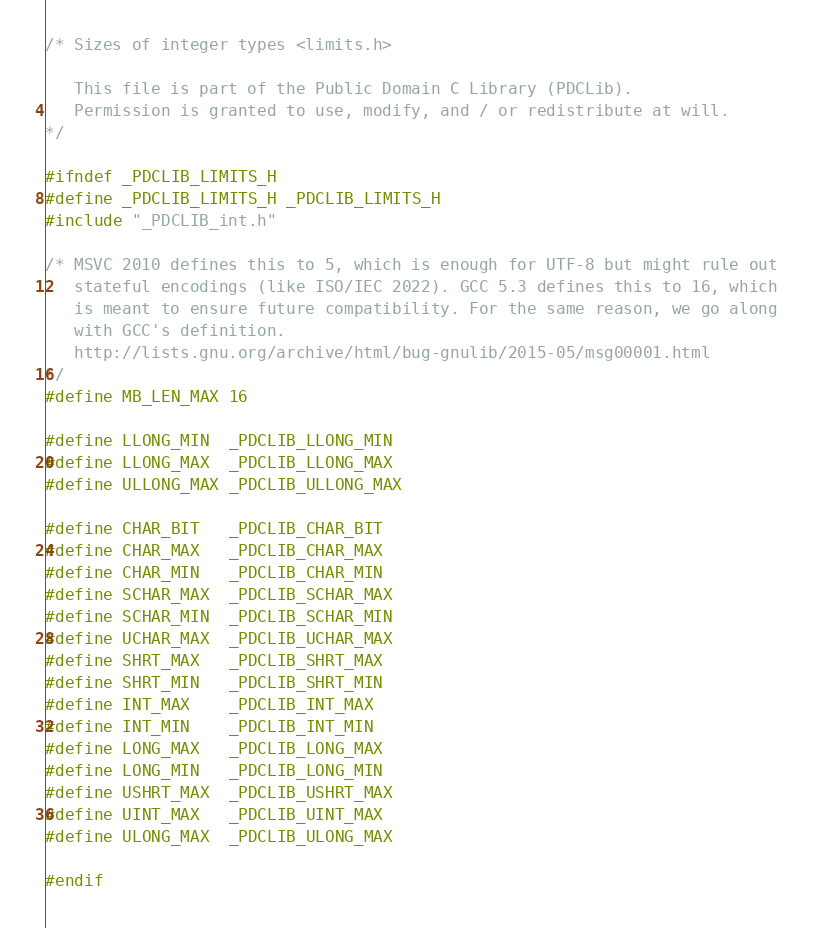Convert code to text. <code><loc_0><loc_0><loc_500><loc_500><_C_>/* Sizes of integer types <limits.h>

   This file is part of the Public Domain C Library (PDCLib).
   Permission is granted to use, modify, and / or redistribute at will.
*/

#ifndef _PDCLIB_LIMITS_H
#define _PDCLIB_LIMITS_H _PDCLIB_LIMITS_H
#include "_PDCLIB_int.h"

/* MSVC 2010 defines this to 5, which is enough for UTF-8 but might rule out
   stateful encodings (like ISO/IEC 2022). GCC 5.3 defines this to 16, which
   is meant to ensure future compatibility. For the same reason, we go along
   with GCC's definition.
   http://lists.gnu.org/archive/html/bug-gnulib/2015-05/msg00001.html
*/
#define MB_LEN_MAX 16

#define LLONG_MIN  _PDCLIB_LLONG_MIN
#define LLONG_MAX  _PDCLIB_LLONG_MAX
#define ULLONG_MAX _PDCLIB_ULLONG_MAX

#define CHAR_BIT   _PDCLIB_CHAR_BIT
#define CHAR_MAX   _PDCLIB_CHAR_MAX
#define CHAR_MIN   _PDCLIB_CHAR_MIN
#define SCHAR_MAX  _PDCLIB_SCHAR_MAX
#define SCHAR_MIN  _PDCLIB_SCHAR_MIN
#define UCHAR_MAX  _PDCLIB_UCHAR_MAX
#define SHRT_MAX   _PDCLIB_SHRT_MAX
#define SHRT_MIN   _PDCLIB_SHRT_MIN
#define INT_MAX    _PDCLIB_INT_MAX
#define INT_MIN    _PDCLIB_INT_MIN
#define LONG_MAX   _PDCLIB_LONG_MAX
#define LONG_MIN   _PDCLIB_LONG_MIN
#define USHRT_MAX  _PDCLIB_USHRT_MAX
#define UINT_MAX   _PDCLIB_UINT_MAX
#define ULONG_MAX  _PDCLIB_ULONG_MAX

#endif
</code> 